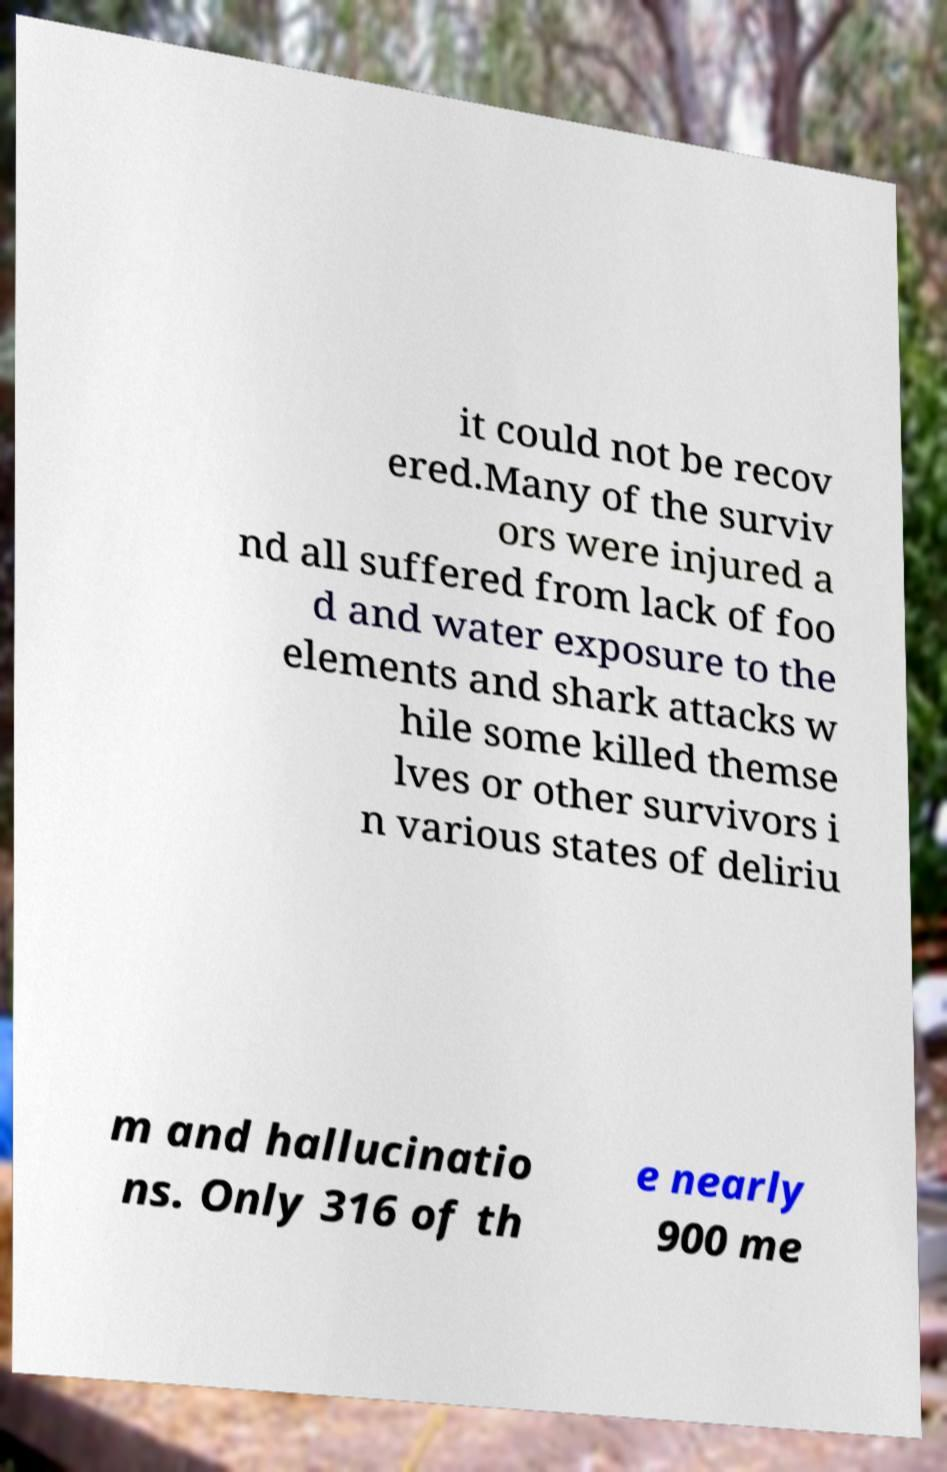Could you assist in decoding the text presented in this image and type it out clearly? it could not be recov ered.Many of the surviv ors were injured a nd all suffered from lack of foo d and water exposure to the elements and shark attacks w hile some killed themse lves or other survivors i n various states of deliriu m and hallucinatio ns. Only 316 of th e nearly 900 me 